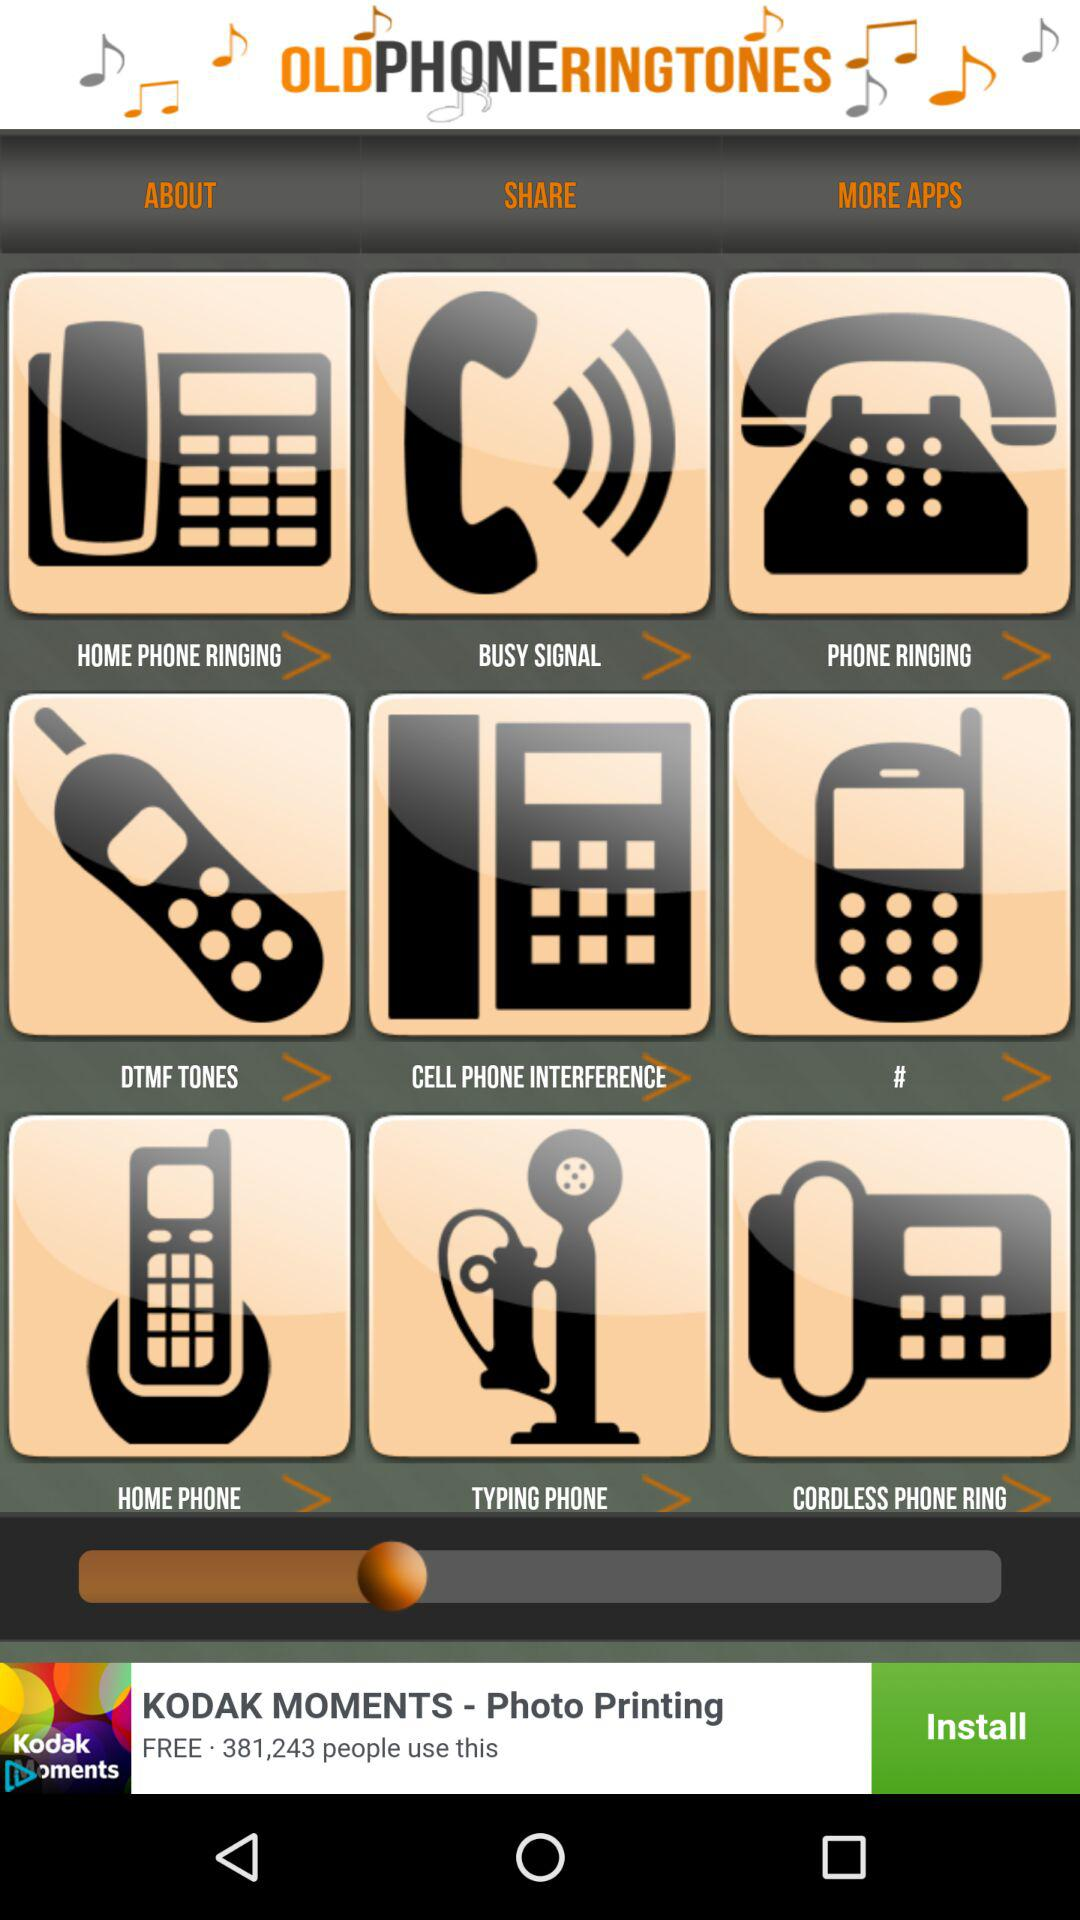What are the different available categories in "OLDPHONERINGTONES"? The different available categories are "HOME PHONE RINGING", "BUSY SIGNAL", "DTMF TONES", "CELL PHONE INTERFERENCE", "#", "HOME PHONE", "TYPING PHONE" and "CORDLESS PHONE RING". 